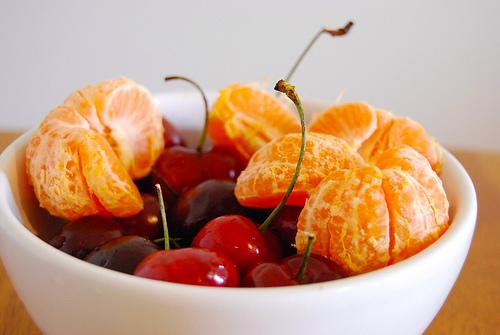What is contained in the red fruit that should not be ingested? pit 